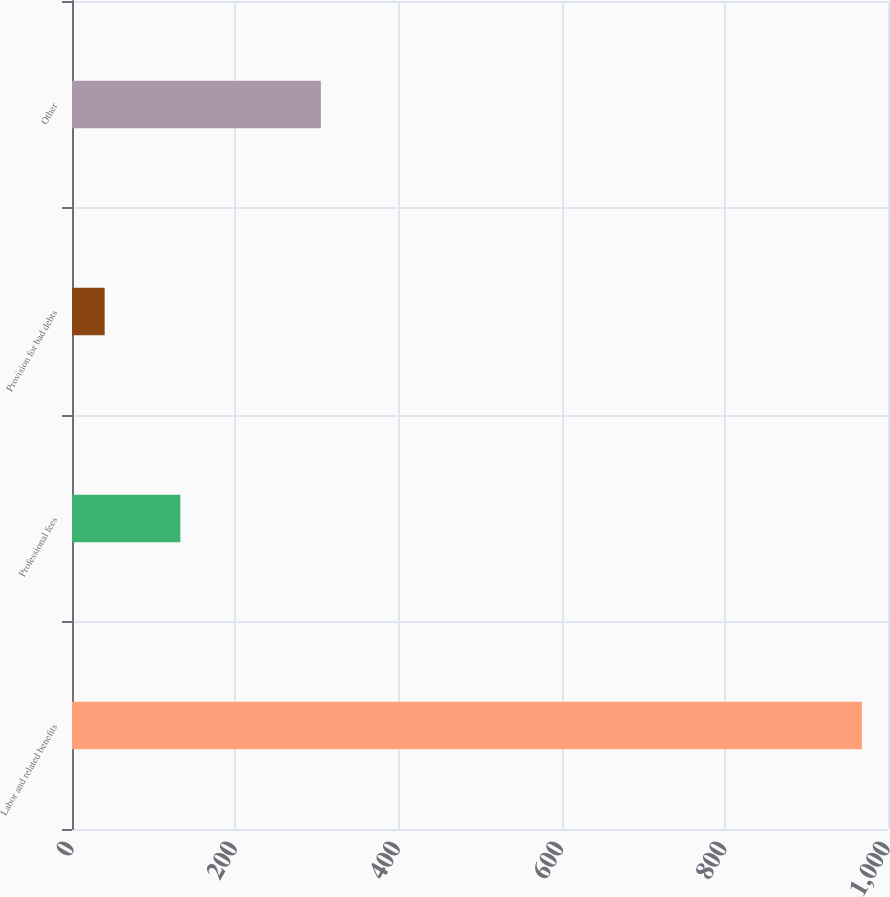<chart> <loc_0><loc_0><loc_500><loc_500><bar_chart><fcel>Labor and related benefits<fcel>Professional fees<fcel>Provision for bad debts<fcel>Other<nl><fcel>968<fcel>132.8<fcel>40<fcel>305<nl></chart> 